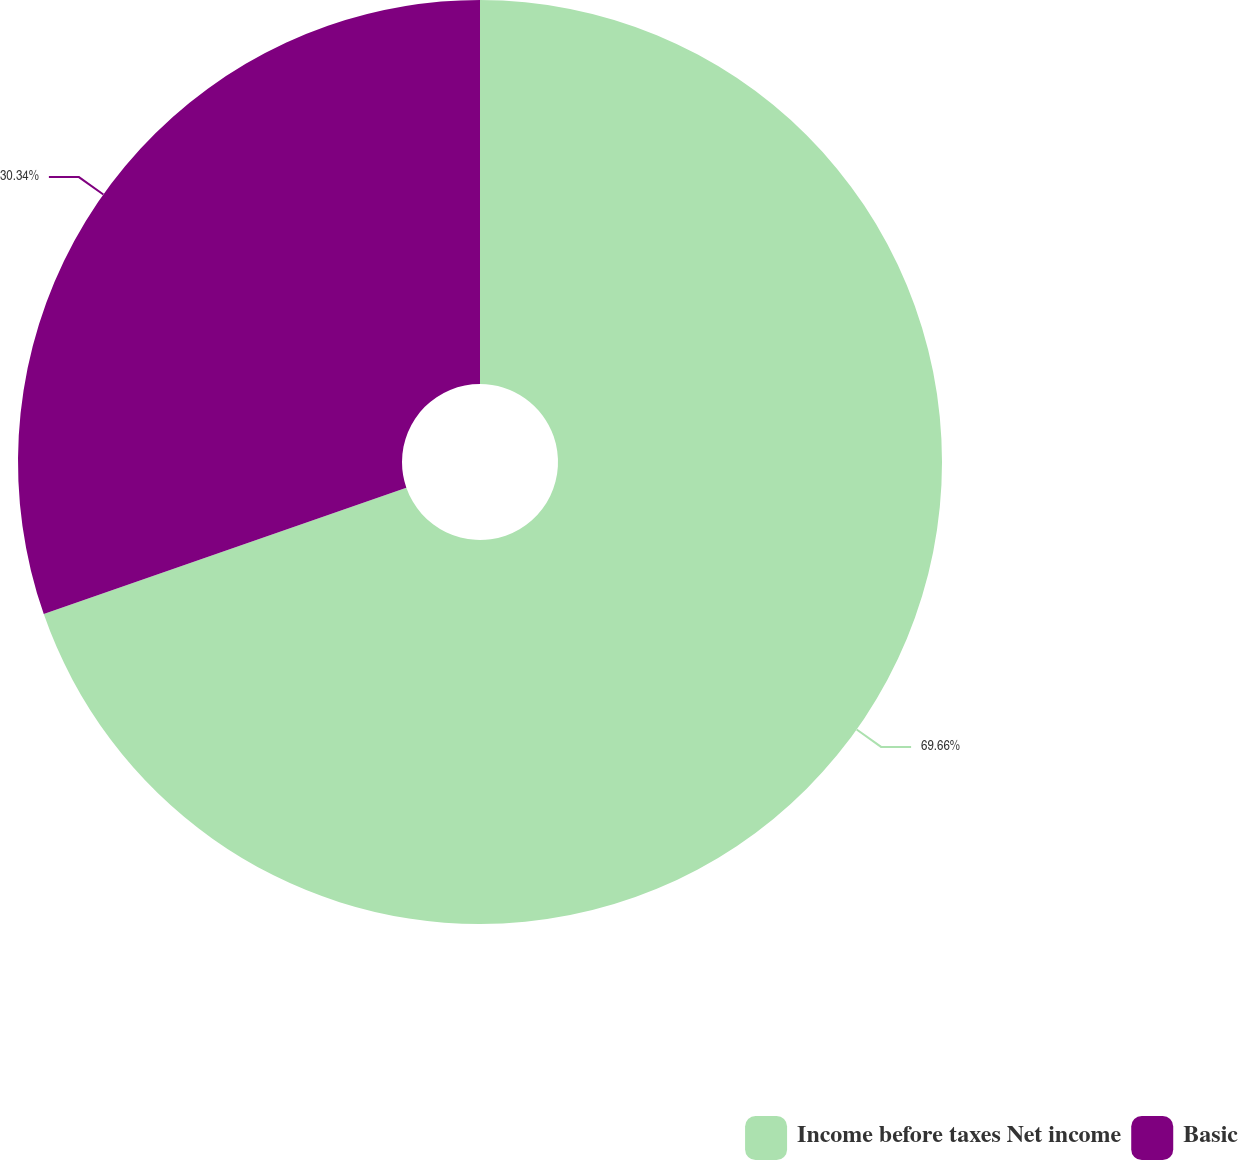Convert chart. <chart><loc_0><loc_0><loc_500><loc_500><pie_chart><fcel>Income before taxes Net income<fcel>Basic<nl><fcel>69.66%<fcel>30.34%<nl></chart> 